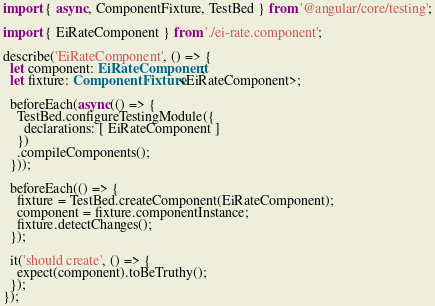<code> <loc_0><loc_0><loc_500><loc_500><_TypeScript_>import { async, ComponentFixture, TestBed } from '@angular/core/testing';

import { EiRateComponent } from './ei-rate.component';

describe('EiRateComponent', () => {
  let component: EiRateComponent;
  let fixture: ComponentFixture<EiRateComponent>;

  beforeEach(async(() => {
    TestBed.configureTestingModule({
      declarations: [ EiRateComponent ]
    })
    .compileComponents();
  }));
 
  beforeEach(() => {
    fixture = TestBed.createComponent(EiRateComponent);
    component = fixture.componentInstance;
    fixture.detectChanges();
  });

  it('should create', () => {
    expect(component).toBeTruthy();
  });
});
</code> 